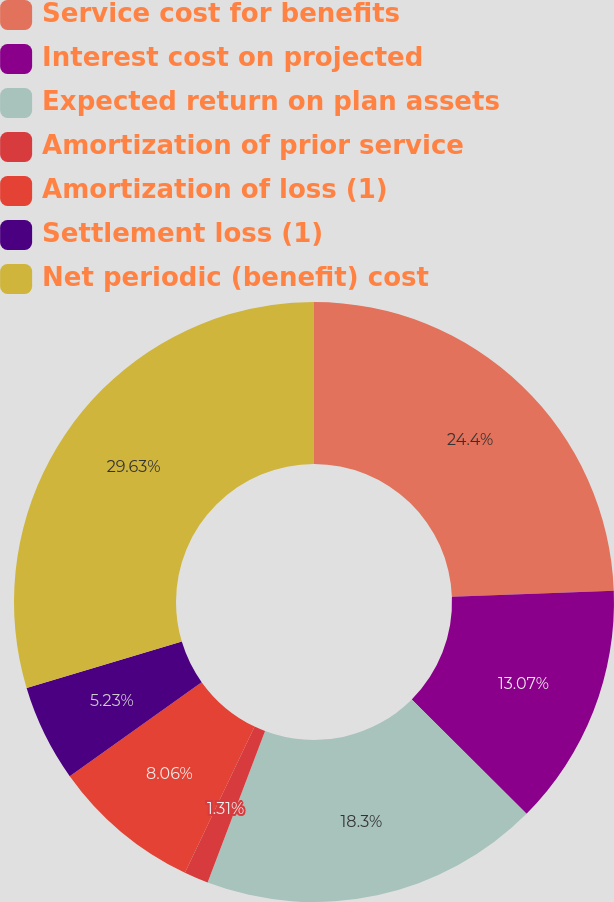<chart> <loc_0><loc_0><loc_500><loc_500><pie_chart><fcel>Service cost for benefits<fcel>Interest cost on projected<fcel>Expected return on plan assets<fcel>Amortization of prior service<fcel>Amortization of loss (1)<fcel>Settlement loss (1)<fcel>Net periodic (benefit) cost<nl><fcel>24.4%<fcel>13.07%<fcel>18.3%<fcel>1.31%<fcel>8.06%<fcel>5.23%<fcel>29.63%<nl></chart> 